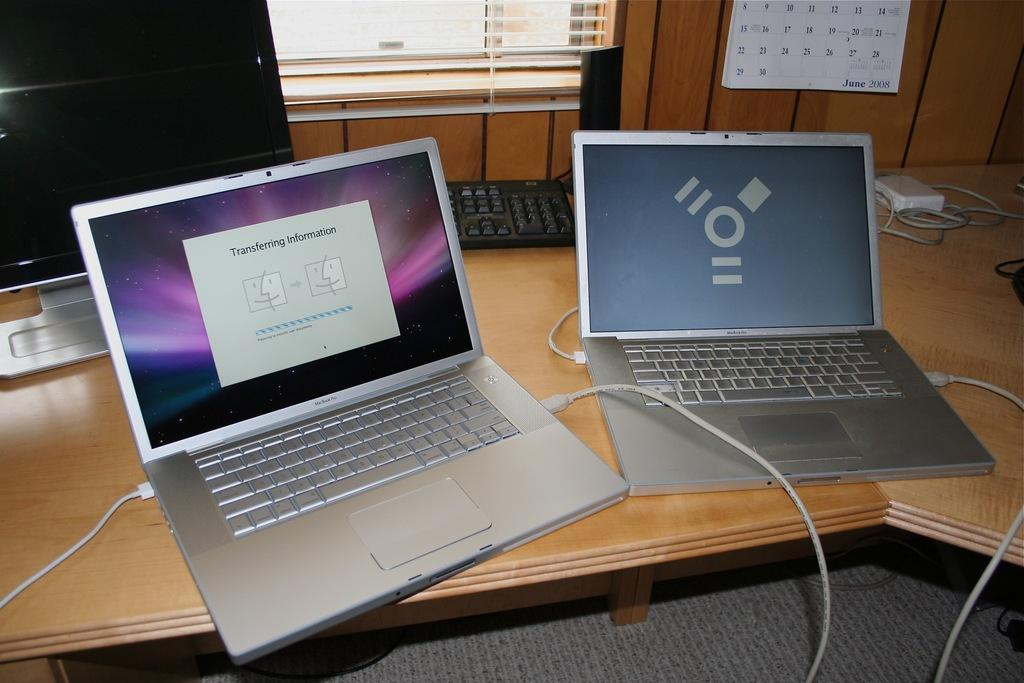How many electronic devices can be seen in the image? There are two laptops and one computer in the image, making a total of three electronic devices. What is located on the top of the image? There is a calendar and a window on the top of the image. What can be seen on the right side of the image? There are wires on the right side of the image. What is in the middle of the image? There is a keyboard in the middle of the image. What type of alley can be seen in the image? There is no alley present in the image; the focus is on electronic devices and other related items. 